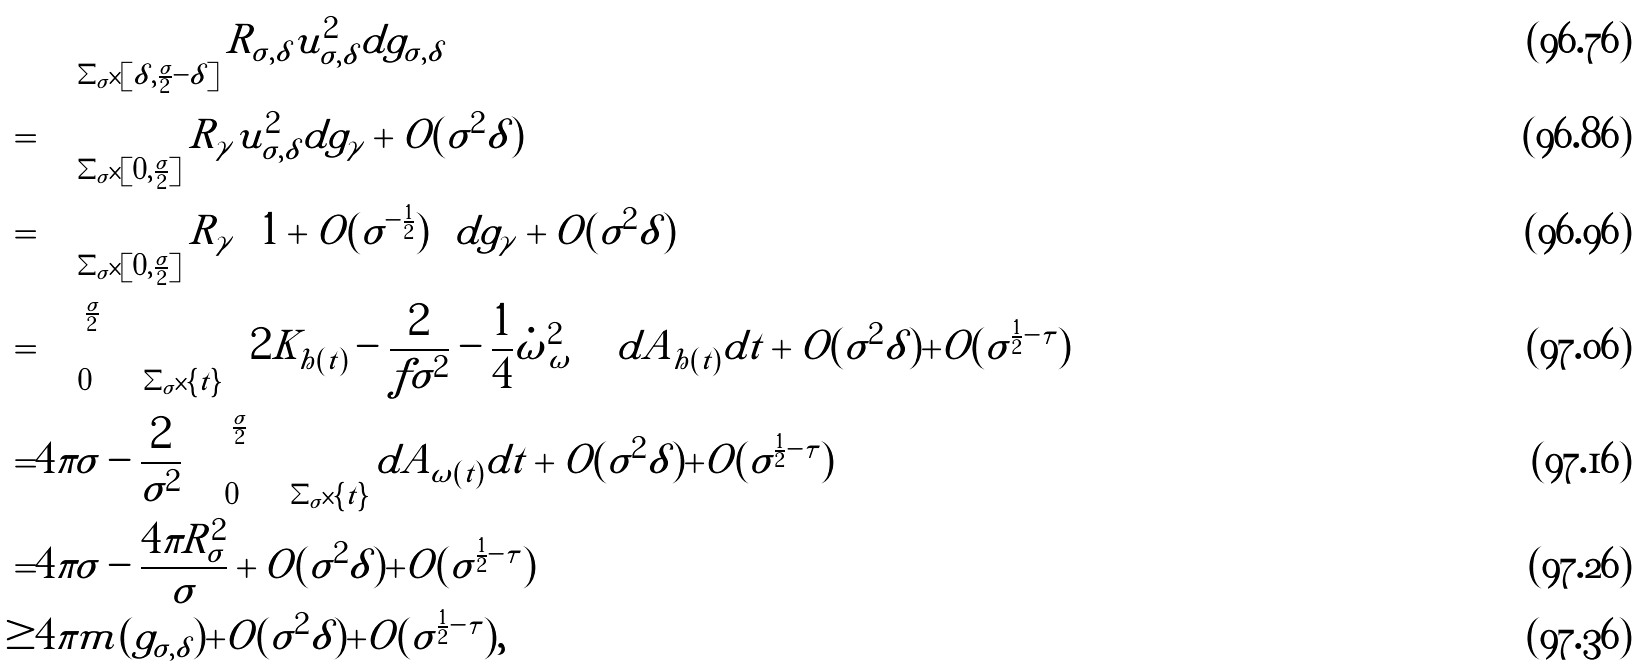Convert formula to latex. <formula><loc_0><loc_0><loc_500><loc_500>& \int _ { \Sigma _ { \sigma } \times [ \delta , \frac { \sigma } { 2 } - \delta ] } R _ { \sigma , \delta } u _ { \sigma , \delta } ^ { 2 } d g _ { \sigma , \delta } \\ = & \int _ { \Sigma _ { \sigma } \times [ 0 , \frac { \sigma } { 2 } ] } R _ { \gamma } u _ { \sigma , \delta } ^ { 2 } d g _ { \gamma } + O ( \sigma ^ { 2 } \delta ) \\ = & \int _ { \Sigma _ { \sigma } \times [ 0 , \frac { \sigma } { 2 } ] } R _ { \gamma } \left ( 1 + O ( \sigma ^ { - \frac { 1 } { 2 } } ) \right ) d g _ { \gamma } + O ( \sigma ^ { 2 } \delta ) \\ = & \int _ { 0 } ^ { \frac { \sigma } { 2 } } \int _ { \Sigma _ { \sigma } \times \{ t \} } \left [ 2 K _ { h ( t ) } - \frac { 2 } { f \sigma ^ { 2 } } - \frac { 1 } { 4 } | \dot { \omega } | _ { \omega } ^ { 2 } \right ] d A _ { h ( t ) } d t + O ( \sigma ^ { 2 } \delta ) + O ( \sigma ^ { \frac { 1 } { 2 } - \tau } ) \\ = & 4 \pi \sigma - \frac { 2 } { \sigma ^ { 2 } } \int _ { 0 } ^ { \frac { \sigma } { 2 } } \int _ { \Sigma _ { \sigma } \times \{ t \} } d A _ { \omega ( t ) } d t + O ( \sigma ^ { 2 } \delta ) + O ( \sigma ^ { \frac { 1 } { 2 } - \tau } ) \\ = & 4 \pi \sigma - \frac { 4 \pi R ^ { 2 } _ { \sigma } } { \sigma } + O ( \sigma ^ { 2 } \delta ) + O ( \sigma ^ { \frac { 1 } { 2 } - \tau } ) \\ \geq & 4 \pi m ( g _ { \sigma , \delta } ) + O ( \sigma ^ { 2 } \delta ) + O ( \sigma ^ { \frac { 1 } { 2 } - \tau } ) ,</formula> 